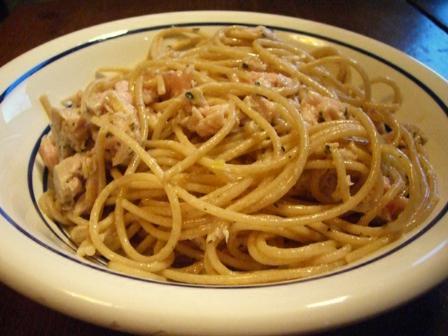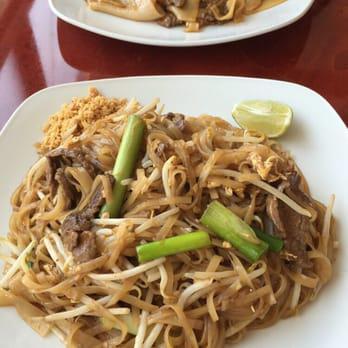The first image is the image on the left, the second image is the image on the right. Considering the images on both sides, is "A silver utinsil is sitting in the bowl in one of the images." valid? Answer yes or no. No. The first image is the image on the left, the second image is the image on the right. For the images displayed, is the sentence "One image shows a pasta dish topped with sliced lemon." factually correct? Answer yes or no. No. 